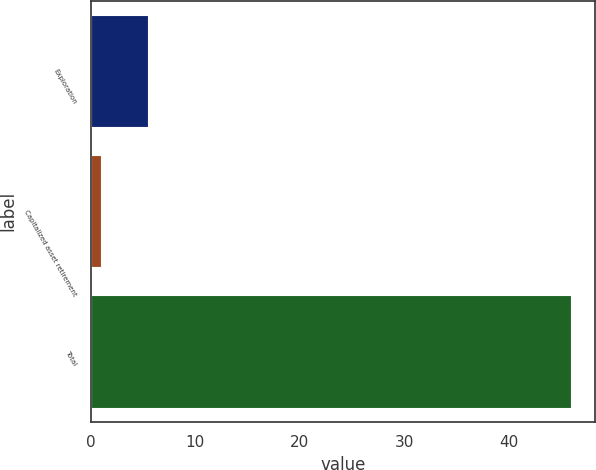Convert chart. <chart><loc_0><loc_0><loc_500><loc_500><bar_chart><fcel>Exploration<fcel>Capitalized asset retirement<fcel>Total<nl><fcel>5.5<fcel>1<fcel>46<nl></chart> 